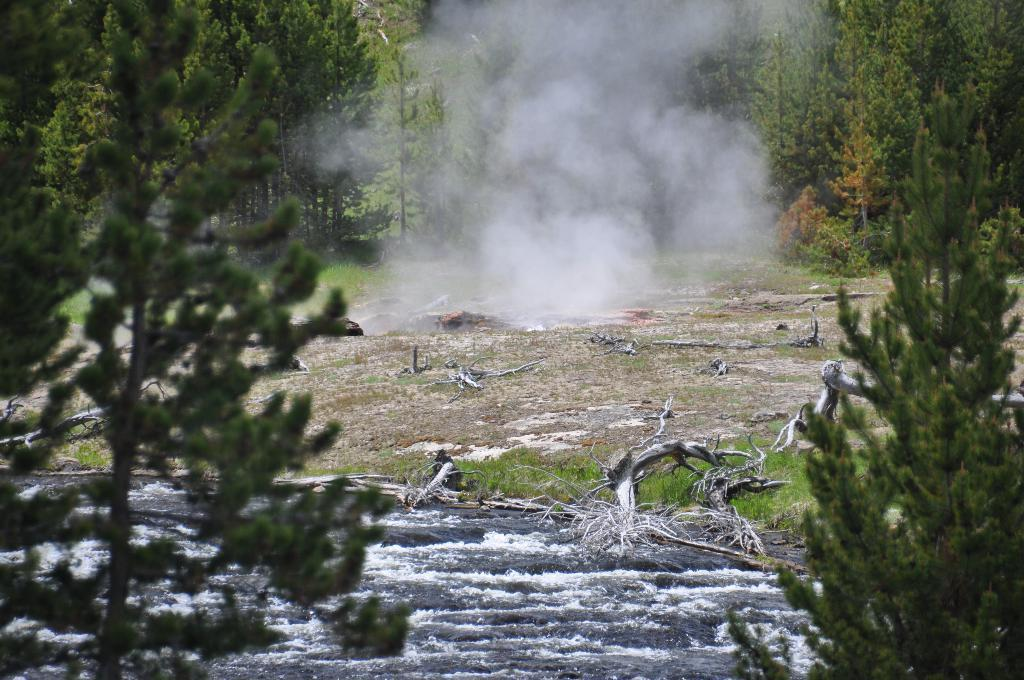What type of vegetation can be seen in the image? There are trees and grass visible in the image. What other objects can be seen on the ground in the image? There are logs and a rock at the bottom of the image. Is there any indication of fire or heat in the image? Yes, there is smoke in the image. What type of berry is growing on the trees in the image? There are no berries visible on the trees in the image. 